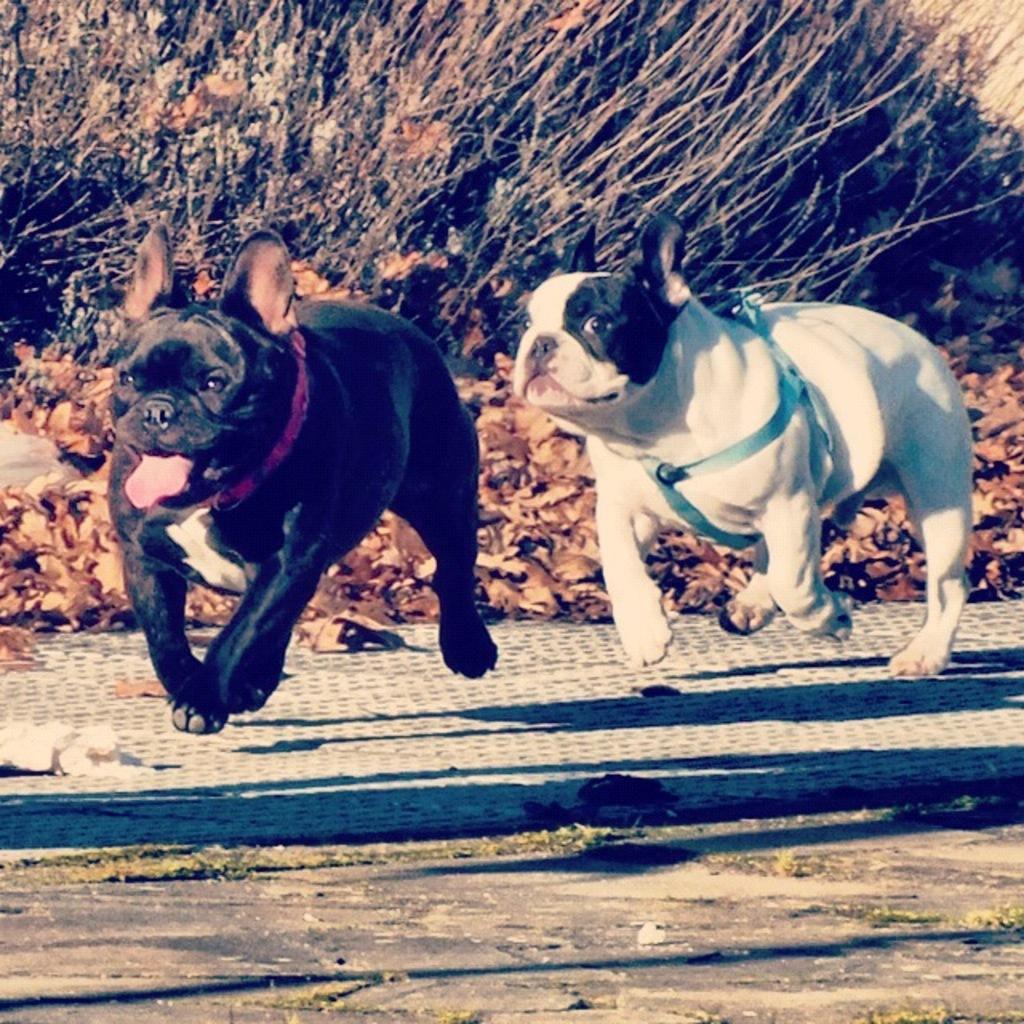Could you give a brief overview of what you see in this image? This image consists of two dogs running. At the bottom, there is a road. In the background, we can see dried leaves and plants. 